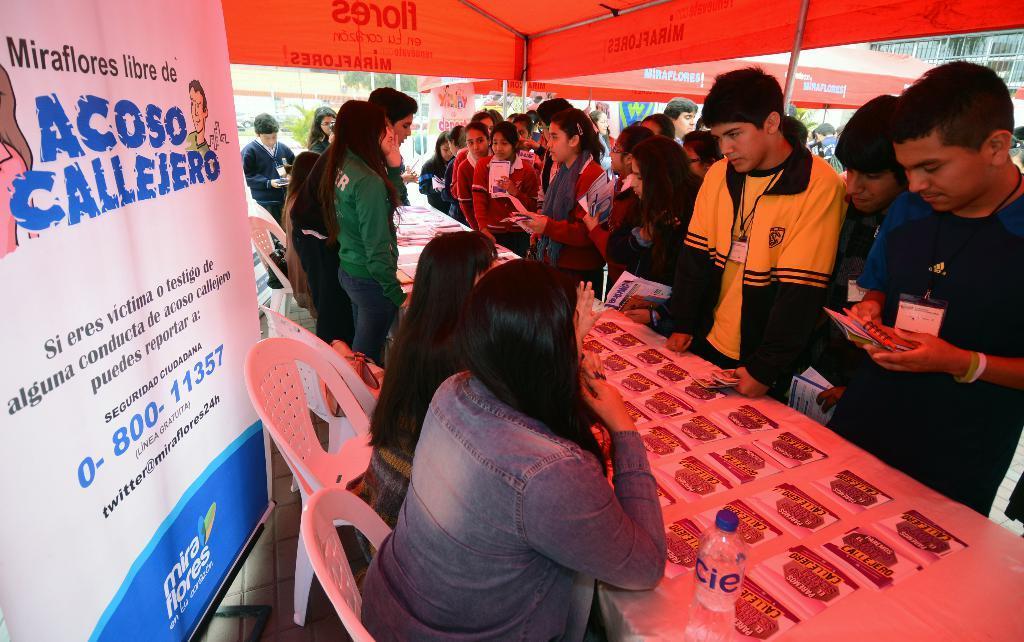In one or two sentences, can you explain what this image depicts? In this image I see number of people in which these 3 women are sitting on chairs and I see that rest of them are standing and few of them are holding few things in their hands and I see many things on these tables and I see a bottle over here and I see the banner over here on which there is something written. In the background I see something is written on this thing and I see the poles. 